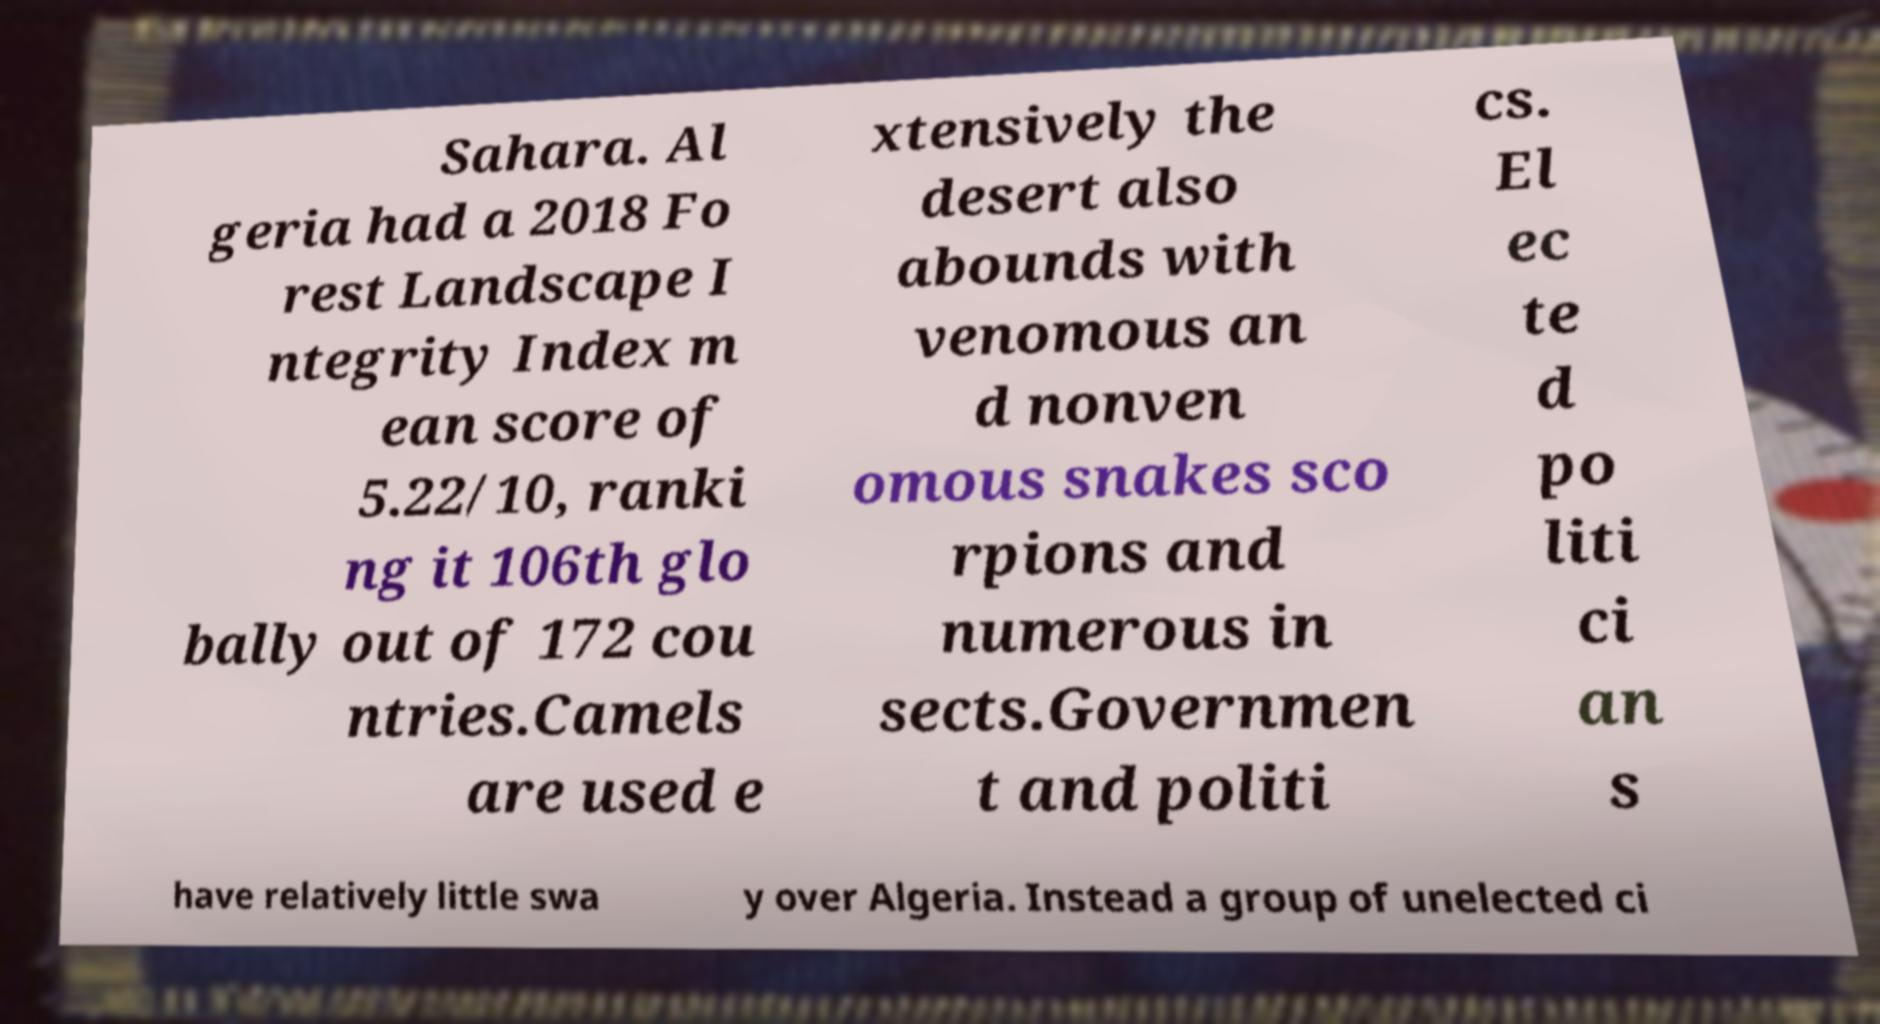I need the written content from this picture converted into text. Can you do that? Sahara. Al geria had a 2018 Fo rest Landscape I ntegrity Index m ean score of 5.22/10, ranki ng it 106th glo bally out of 172 cou ntries.Camels are used e xtensively the desert also abounds with venomous an d nonven omous snakes sco rpions and numerous in sects.Governmen t and politi cs. El ec te d po liti ci an s have relatively little swa y over Algeria. Instead a group of unelected ci 